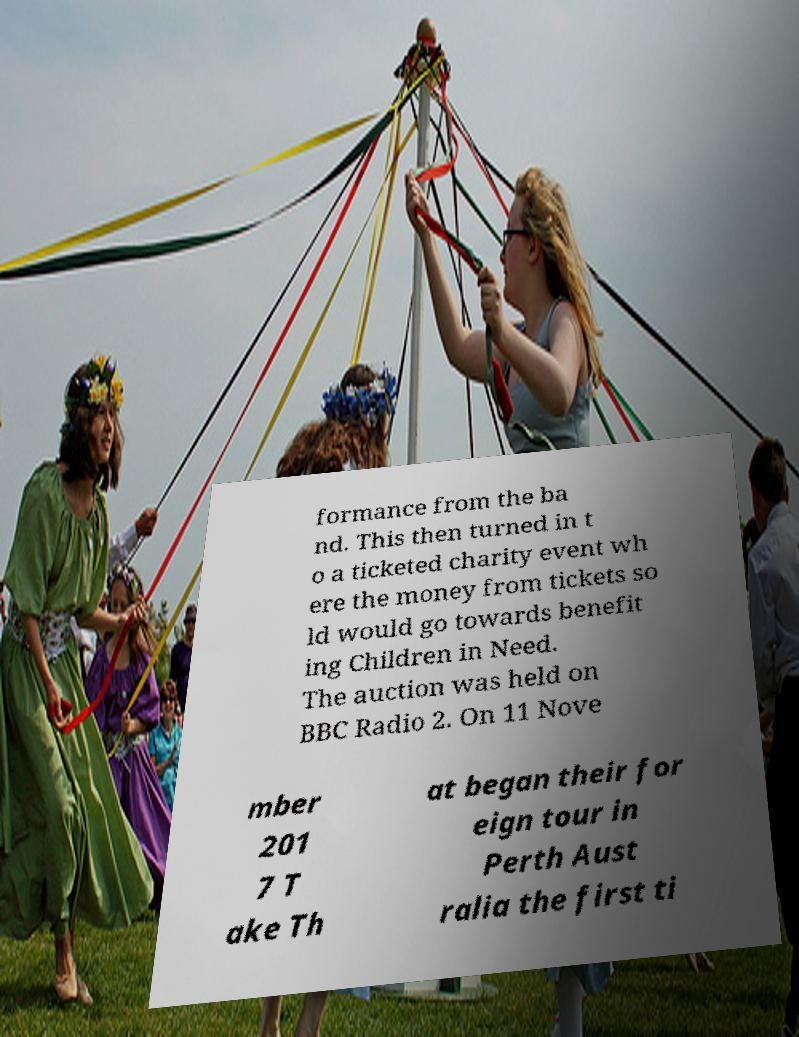Please identify and transcribe the text found in this image. formance from the ba nd. This then turned in t o a ticketed charity event wh ere the money from tickets so ld would go towards benefit ing Children in Need. The auction was held on BBC Radio 2. On 11 Nove mber 201 7 T ake Th at began their for eign tour in Perth Aust ralia the first ti 